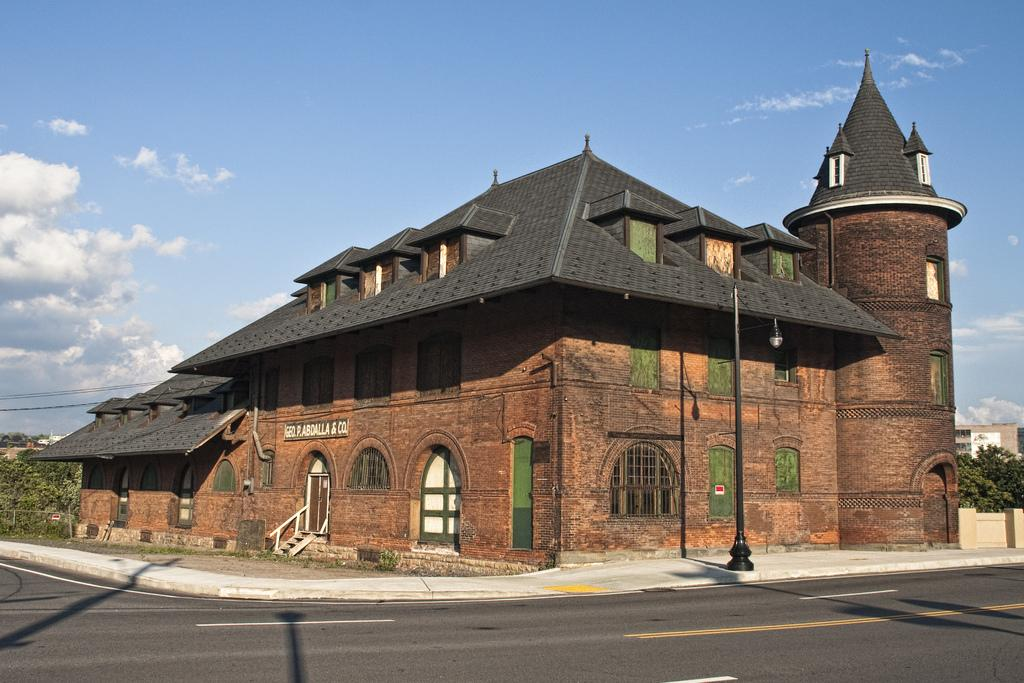What is the main structure in the image? There is a castle in the image. What feature of the castle is mentioned in the facts? The castle has many windows. What is located in front of the castle? There is a road in front of the castle. What can be seen in the background of the image? There are trees in the background of the image. What type of lock is used to secure the castle's entrance in the image? There is no mention of a lock or the castle's entrance in the provided facts, so it cannot be determined from the image. How many additions have been made to the castle in the image? There is no information about any additions to the castle in the provided facts, so it cannot be determined from the image. 